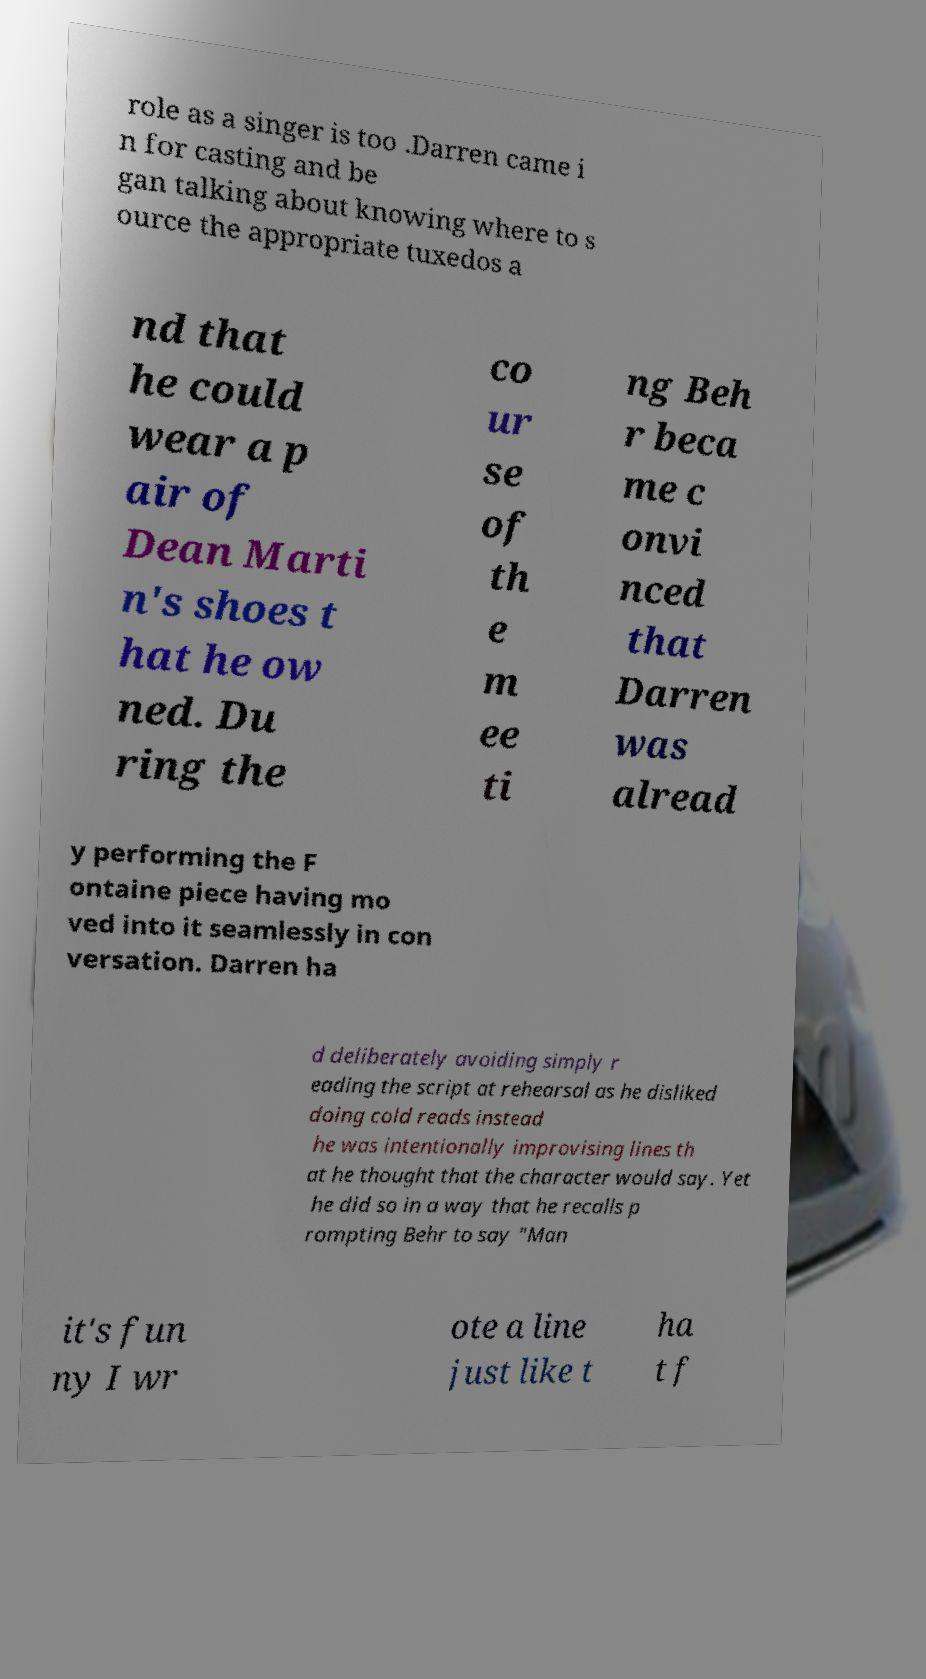I need the written content from this picture converted into text. Can you do that? role as a singer is too .Darren came i n for casting and be gan talking about knowing where to s ource the appropriate tuxedos a nd that he could wear a p air of Dean Marti n's shoes t hat he ow ned. Du ring the co ur se of th e m ee ti ng Beh r beca me c onvi nced that Darren was alread y performing the F ontaine piece having mo ved into it seamlessly in con versation. Darren ha d deliberately avoiding simply r eading the script at rehearsal as he disliked doing cold reads instead he was intentionally improvising lines th at he thought that the character would say. Yet he did so in a way that he recalls p rompting Behr to say "Man it's fun ny I wr ote a line just like t ha t f 